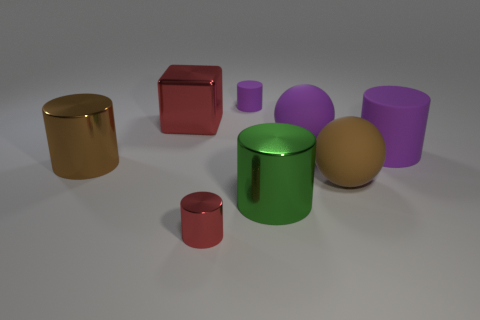Subtract all big brown metallic cylinders. How many cylinders are left? 4 Subtract all yellow blocks. How many purple cylinders are left? 2 Add 1 big yellow matte spheres. How many objects exist? 9 Subtract all purple spheres. How many spheres are left? 1 Subtract all cylinders. How many objects are left? 3 Subtract 1 cylinders. How many cylinders are left? 4 Subtract all purple balls. Subtract all brown cylinders. How many balls are left? 1 Add 1 tiny red cylinders. How many tiny red cylinders are left? 2 Add 7 large shiny things. How many large shiny things exist? 10 Subtract 1 purple cylinders. How many objects are left? 7 